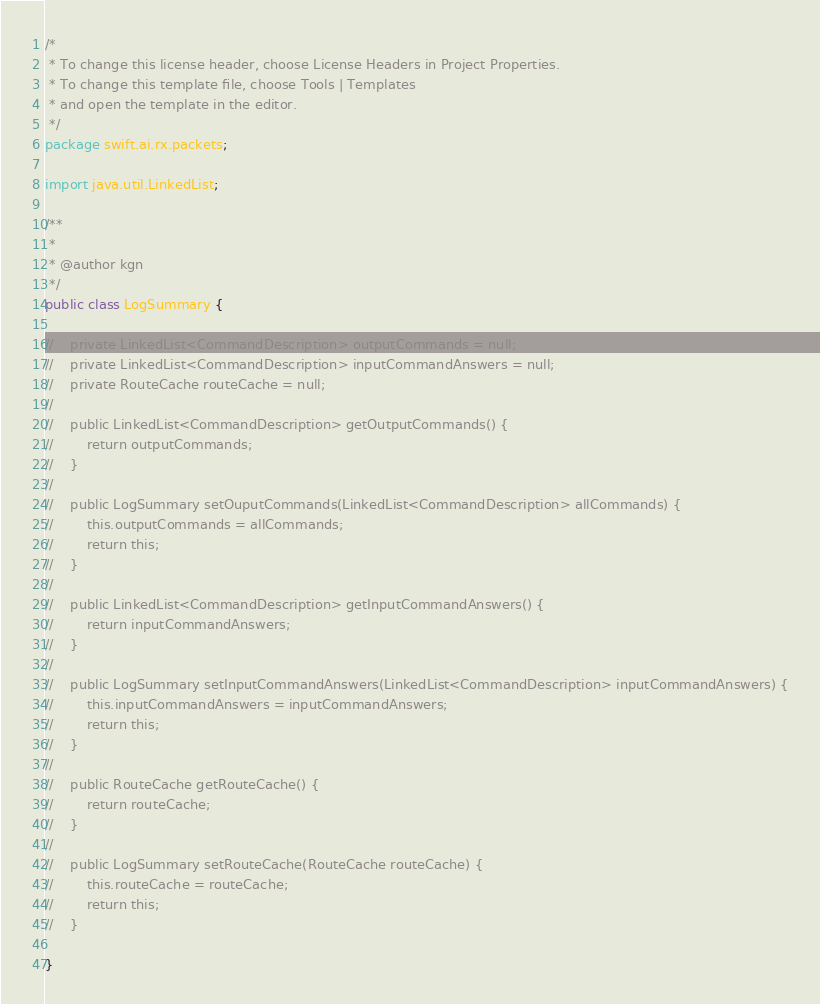Convert code to text. <code><loc_0><loc_0><loc_500><loc_500><_Java_>/*
 * To change this license header, choose License Headers in Project Properties.
 * To change this template file, choose Tools | Templates
 * and open the template in the editor.
 */
package swift.ai.rx.packets;

import java.util.LinkedList;

/**
 *
 * @author kgn
 */
public class LogSummary {
    
//    private LinkedList<CommandDescription> outputCommands = null;
//    private LinkedList<CommandDescription> inputCommandAnswers = null;
//    private RouteCache routeCache = null;
//
//    public LinkedList<CommandDescription> getOutputCommands() {
//        return outputCommands;
//    }
//
//    public LogSummary setOuputCommands(LinkedList<CommandDescription> allCommands) {
//        this.outputCommands = allCommands;
//        return this;
//    }
//
//    public LinkedList<CommandDescription> getInputCommandAnswers() {
//        return inputCommandAnswers;
//    }
//
//    public LogSummary setInputCommandAnswers(LinkedList<CommandDescription> inputCommandAnswers) {
//        this.inputCommandAnswers = inputCommandAnswers;
//        return this;
//    }
//
//    public RouteCache getRouteCache() {
//        return routeCache;
//    }
//
//    public LogSummary setRouteCache(RouteCache routeCache) {
//        this.routeCache = routeCache;
//        return this;
//    }
    
}
</code> 